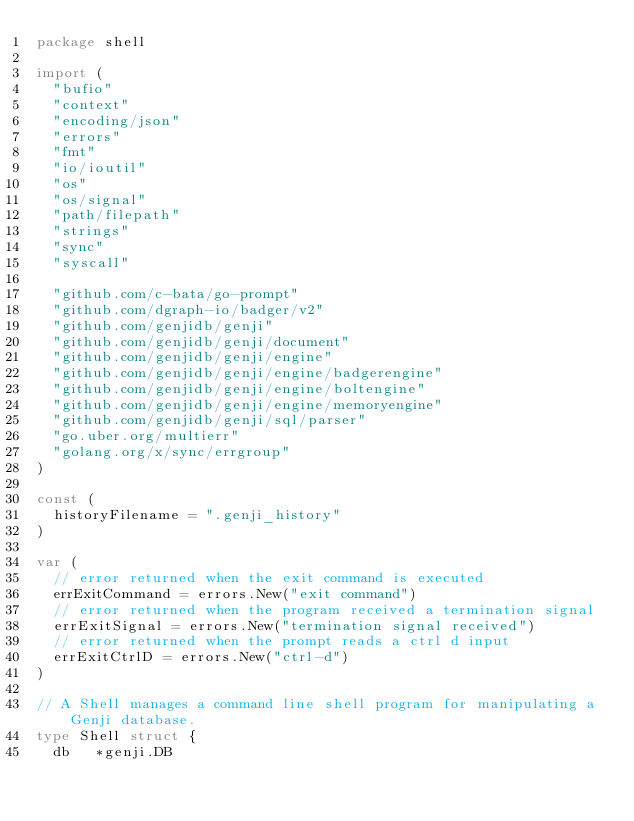<code> <loc_0><loc_0><loc_500><loc_500><_Go_>package shell

import (
	"bufio"
	"context"
	"encoding/json"
	"errors"
	"fmt"
	"io/ioutil"
	"os"
	"os/signal"
	"path/filepath"
	"strings"
	"sync"
	"syscall"

	"github.com/c-bata/go-prompt"
	"github.com/dgraph-io/badger/v2"
	"github.com/genjidb/genji"
	"github.com/genjidb/genji/document"
	"github.com/genjidb/genji/engine"
	"github.com/genjidb/genji/engine/badgerengine"
	"github.com/genjidb/genji/engine/boltengine"
	"github.com/genjidb/genji/engine/memoryengine"
	"github.com/genjidb/genji/sql/parser"
	"go.uber.org/multierr"
	"golang.org/x/sync/errgroup"
)

const (
	historyFilename = ".genji_history"
)

var (
	// error returned when the exit command is executed
	errExitCommand = errors.New("exit command")
	// error returned when the program received a termination signal
	errExitSignal = errors.New("termination signal received")
	// error returned when the prompt reads a ctrl d input
	errExitCtrlD = errors.New("ctrl-d")
)

// A Shell manages a command line shell program for manipulating a Genji database.
type Shell struct {
	db   *genji.DB</code> 